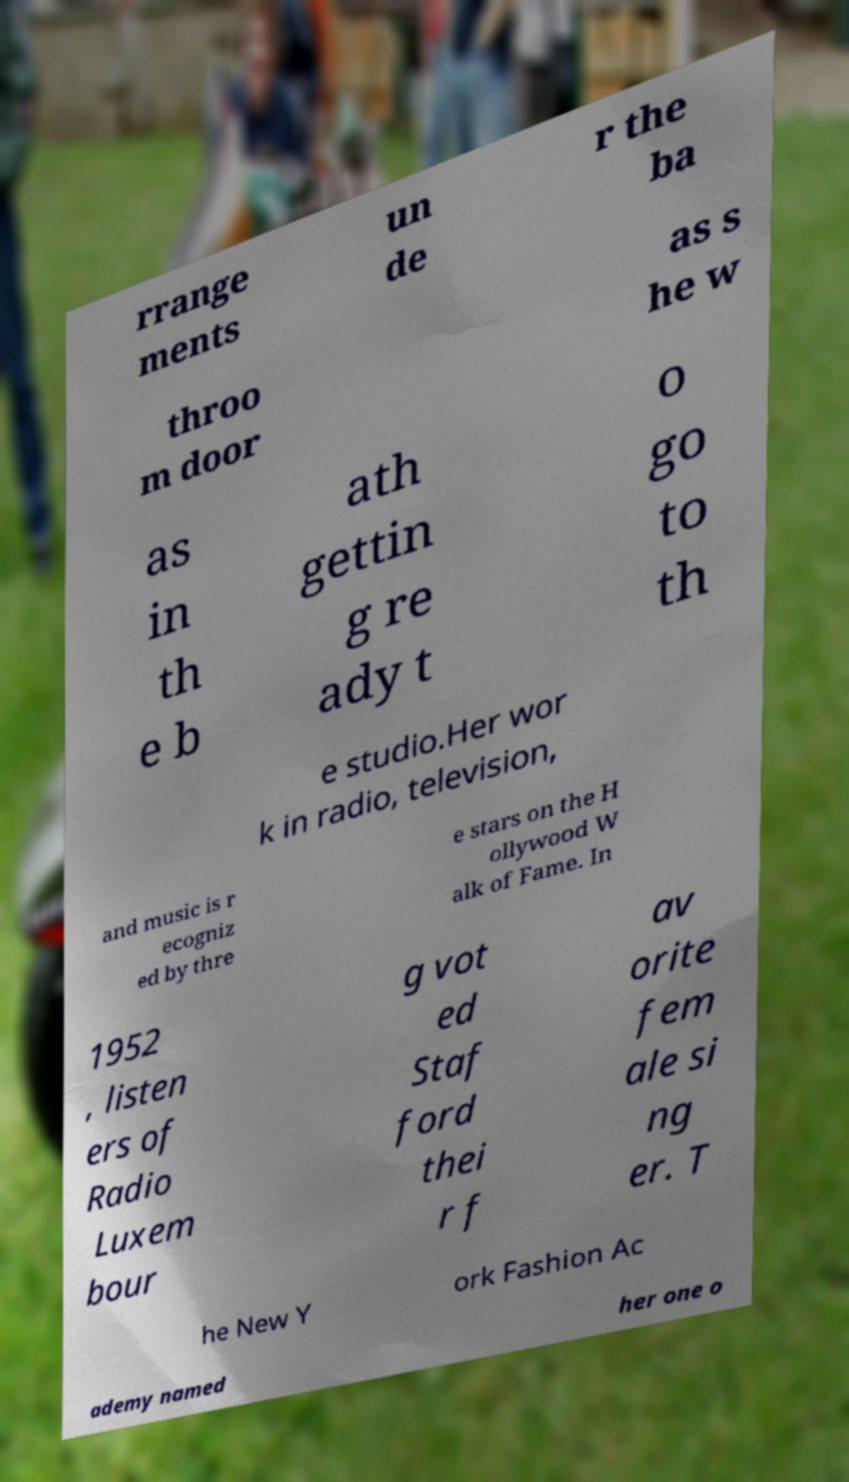Can you read and provide the text displayed in the image?This photo seems to have some interesting text. Can you extract and type it out for me? rrange ments un de r the ba throo m door as s he w as in th e b ath gettin g re ady t o go to th e studio.Her wor k in radio, television, and music is r ecogniz ed by thre e stars on the H ollywood W alk of Fame. In 1952 , listen ers of Radio Luxem bour g vot ed Staf ford thei r f av orite fem ale si ng er. T he New Y ork Fashion Ac ademy named her one o 